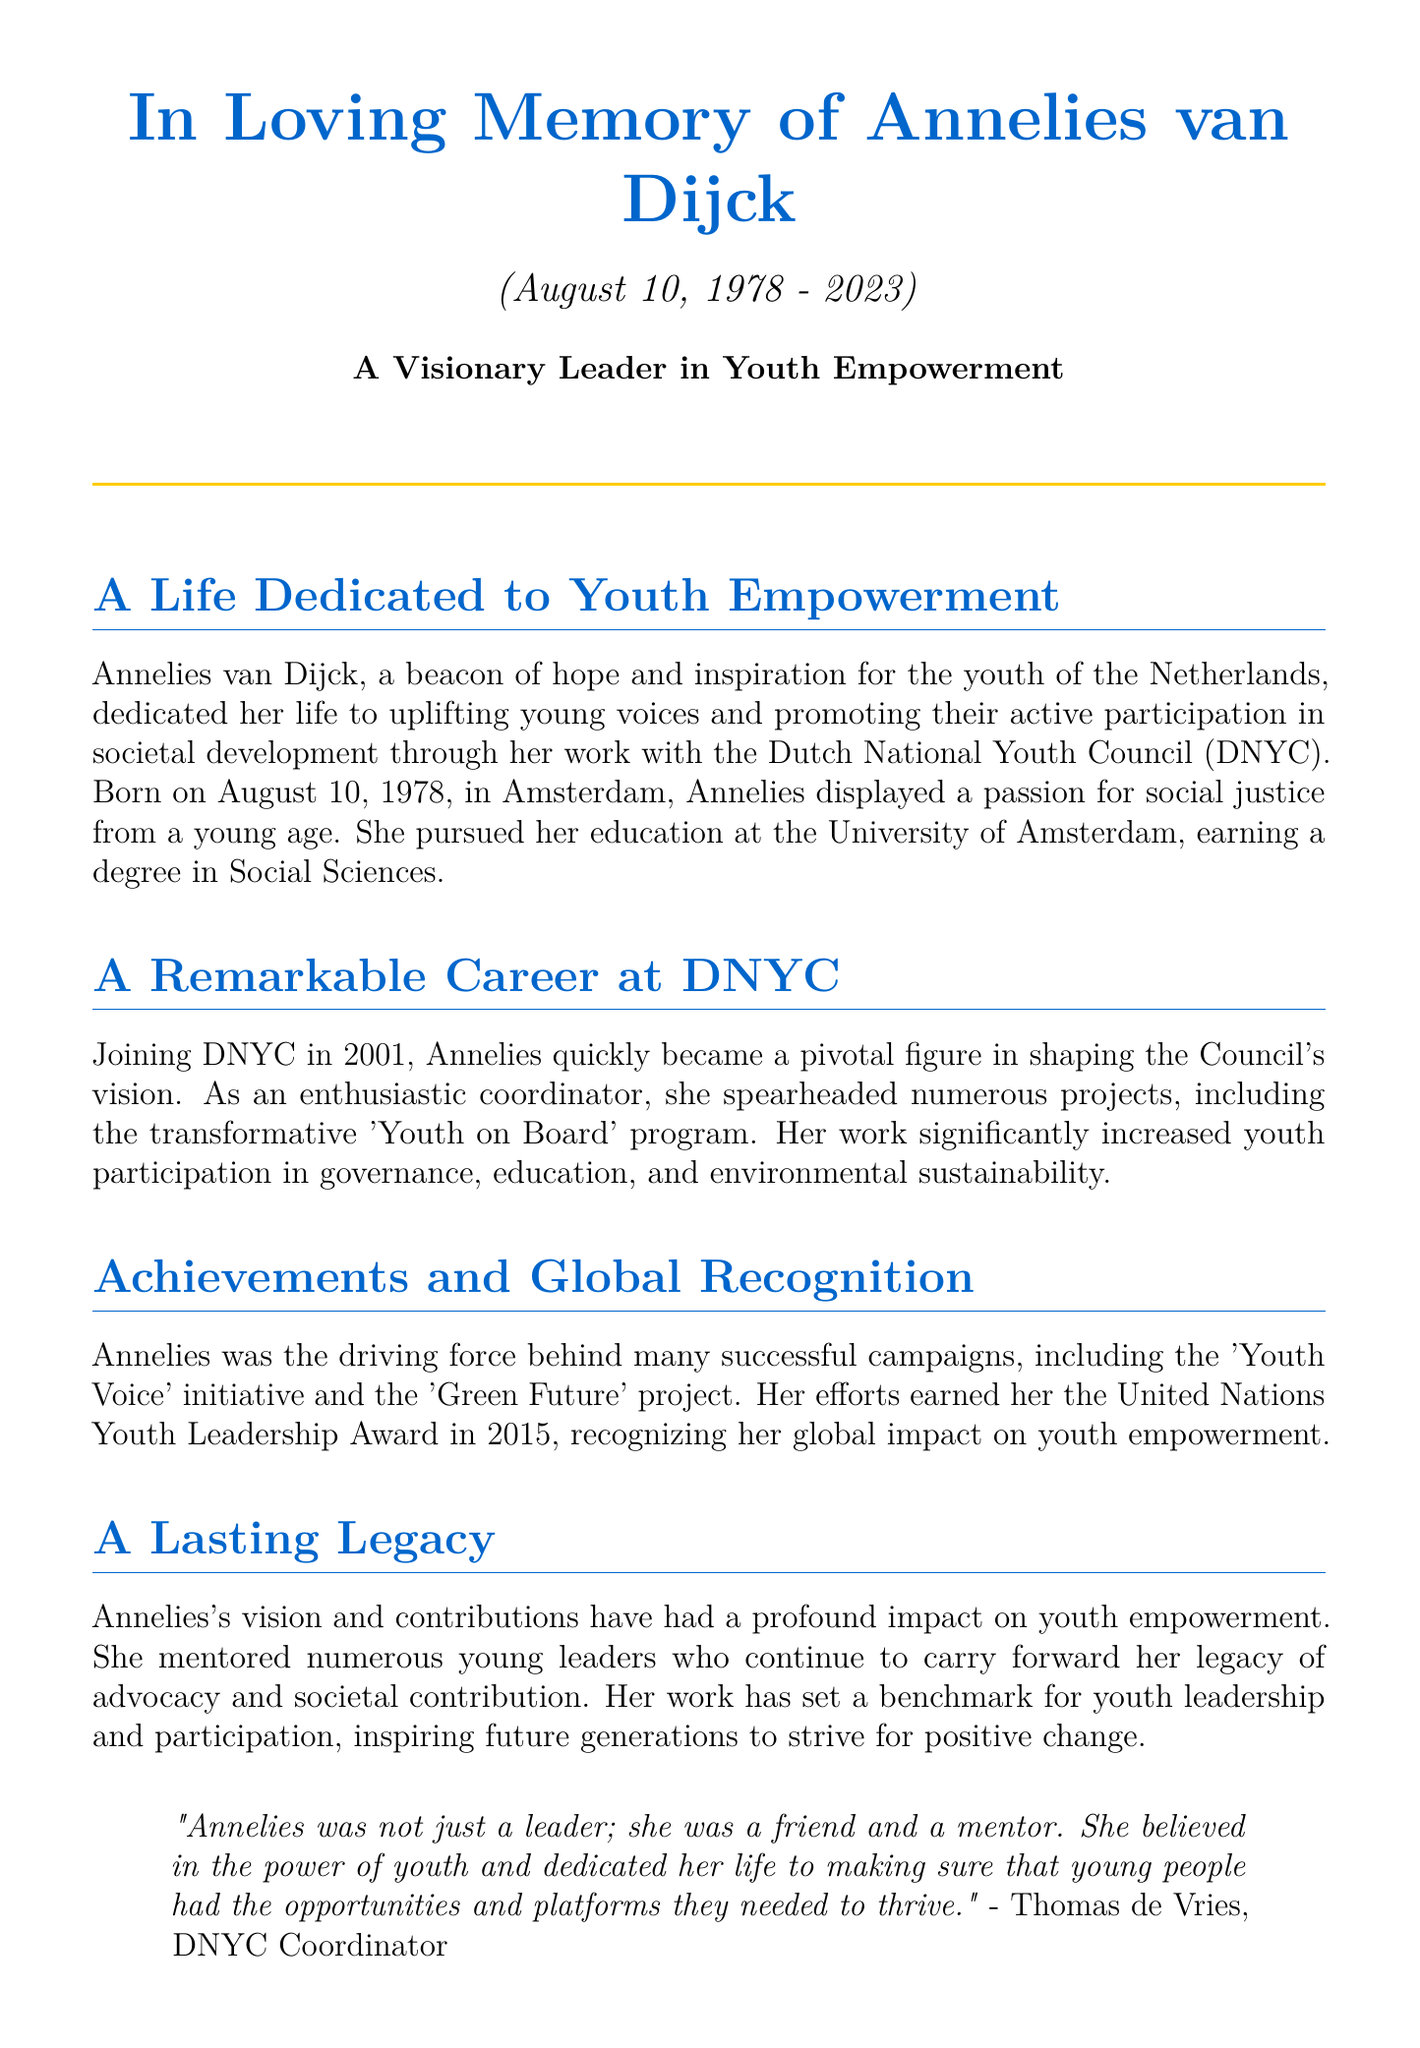What is the full name of the leader being commemorated? The document introduces Annelies van Dijck as the visionary leader in youth empowerment.
Answer: Annelies van Dijck When was Annelies van Dijck born? The document states her birth date as August 10, 1978.
Answer: August 10, 1978 What organization did Annelies work for? Annelies is identified as a pivotal figure in the Dutch National Youth Council (DNYC).
Answer: Dutch National Youth Council (DNYC) What significant program did she lead at DNYC? The document mentions the 'Youth on Board' program as a transformative project she spearheaded.
Answer: Youth on Board In which year did Annelies receive the United Nations Youth Leadership Award? The document states that she received this award in 2015.
Answer: 2015 What was a key initiative she drove related to environmental issues? The document refers to the 'Green Future' project as one of her successful campaigns.
Answer: Green Future Who mentioned a quote about Annelies, and what was their role? The quote is attributed to Thomas de Vries, who is identified as a DNYC Coordinator.
Answer: Thomas de Vries What was a central theme of Annelies van Dijck's work? The document emphasizes her focus on youth empowerment and active participation.
Answer: Youth empowerment What does the quote in the document convey about Annelies? The quote suggests she was not only a leader but also a friend and mentor who believed in youth.
Answer: Friend and mentor 